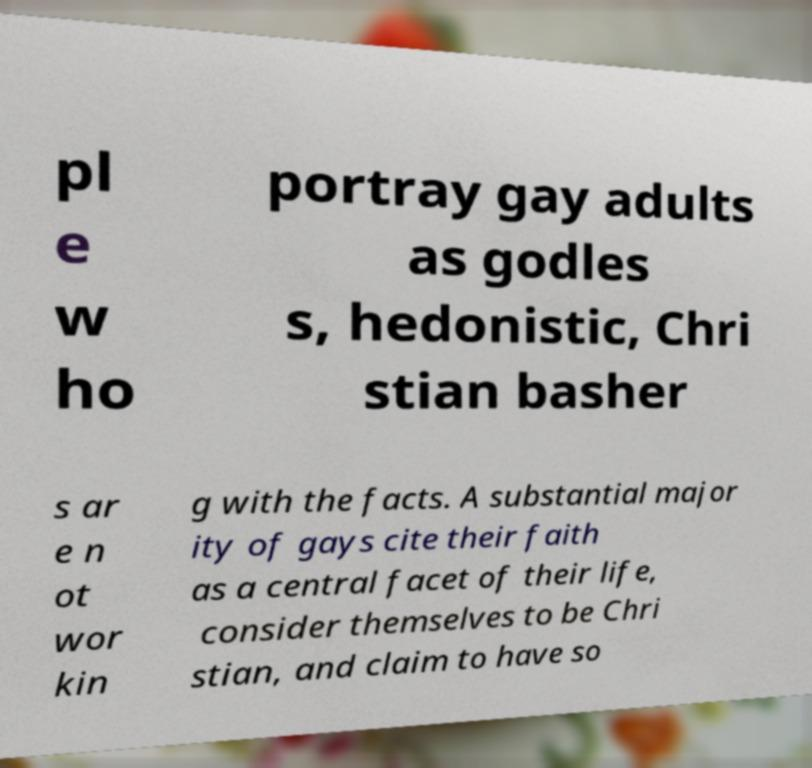Please read and relay the text visible in this image. What does it say? pl e w ho portray gay adults as godles s, hedonistic, Chri stian basher s ar e n ot wor kin g with the facts. A substantial major ity of gays cite their faith as a central facet of their life, consider themselves to be Chri stian, and claim to have so 